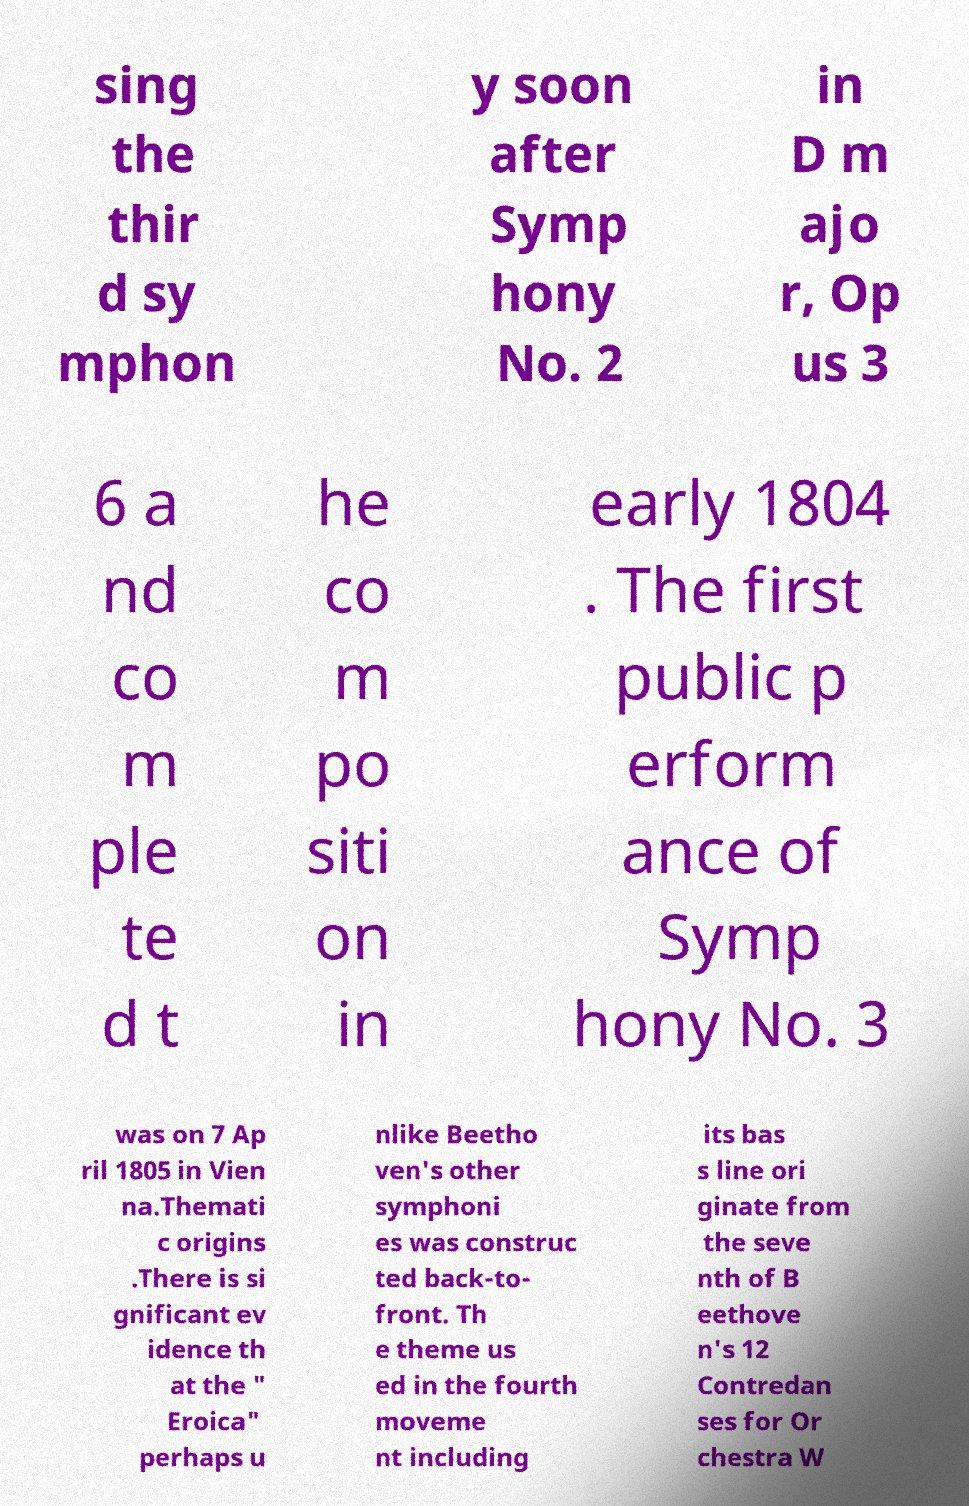Can you read and provide the text displayed in the image?This photo seems to have some interesting text. Can you extract and type it out for me? sing the thir d sy mphon y soon after Symp hony No. 2 in D m ajo r, Op us 3 6 a nd co m ple te d t he co m po siti on in early 1804 . The first public p erform ance of Symp hony No. 3 was on 7 Ap ril 1805 in Vien na.Themati c origins .There is si gnificant ev idence th at the " Eroica" perhaps u nlike Beetho ven's other symphoni es was construc ted back-to- front. Th e theme us ed in the fourth moveme nt including its bas s line ori ginate from the seve nth of B eethove n's 12 Contredan ses for Or chestra W 